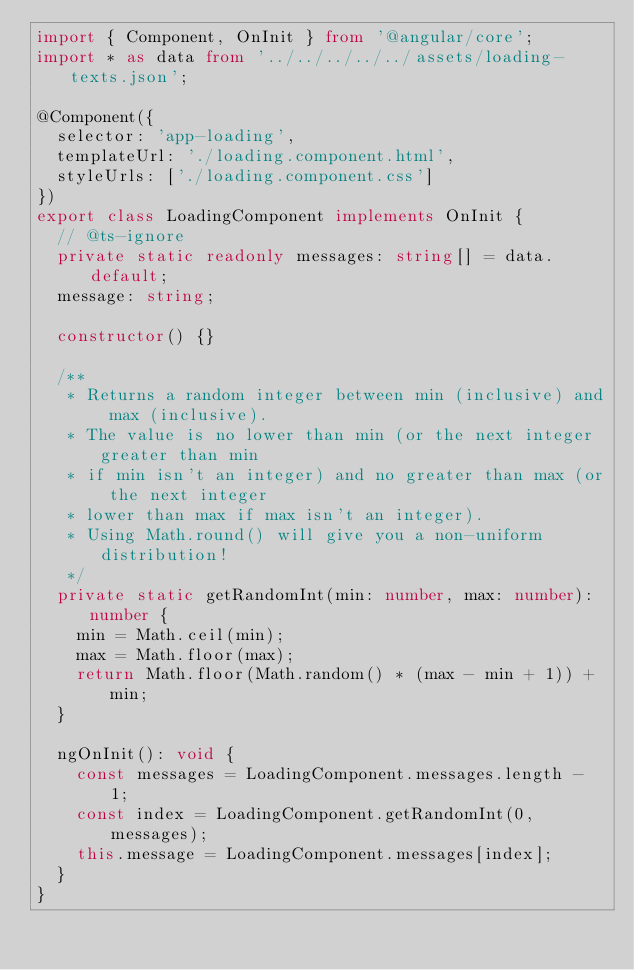<code> <loc_0><loc_0><loc_500><loc_500><_TypeScript_>import { Component, OnInit } from '@angular/core';
import * as data from '../../../../../assets/loading-texts.json';

@Component({
	selector: 'app-loading',
	templateUrl: './loading.component.html',
	styleUrls: ['./loading.component.css']
})
export class LoadingComponent implements OnInit {
	// @ts-ignore
	private static readonly messages: string[] = data.default;
	message: string;

	constructor() {}

	/**
	 * Returns a random integer between min (inclusive) and max (inclusive).
	 * The value is no lower than min (or the next integer greater than min
	 * if min isn't an integer) and no greater than max (or the next integer
	 * lower than max if max isn't an integer).
	 * Using Math.round() will give you a non-uniform distribution!
	 */
	private static getRandomInt(min: number, max: number): number {
		min = Math.ceil(min);
		max = Math.floor(max);
		return Math.floor(Math.random() * (max - min + 1)) + min;
	}

	ngOnInit(): void {
		const messages = LoadingComponent.messages.length - 1;
		const index = LoadingComponent.getRandomInt(0, messages);
		this.message = LoadingComponent.messages[index];
	}
}
</code> 